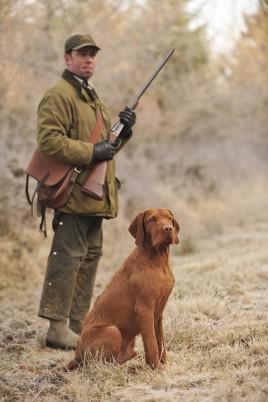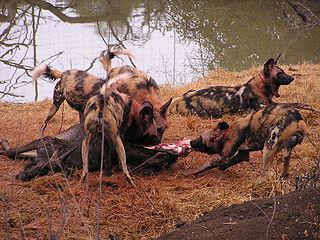The first image is the image on the left, the second image is the image on the right. Assess this claim about the two images: "A dog walks through the grass as it carries something in its mouth.". Correct or not? Answer yes or no. No. The first image is the image on the left, the second image is the image on the right. For the images shown, is this caption "The left image shows two look-alike dogs side-by-side, gazing in the same direction, and the right image shows one brown dog walking with an animal figure in its mouth." true? Answer yes or no. No. 